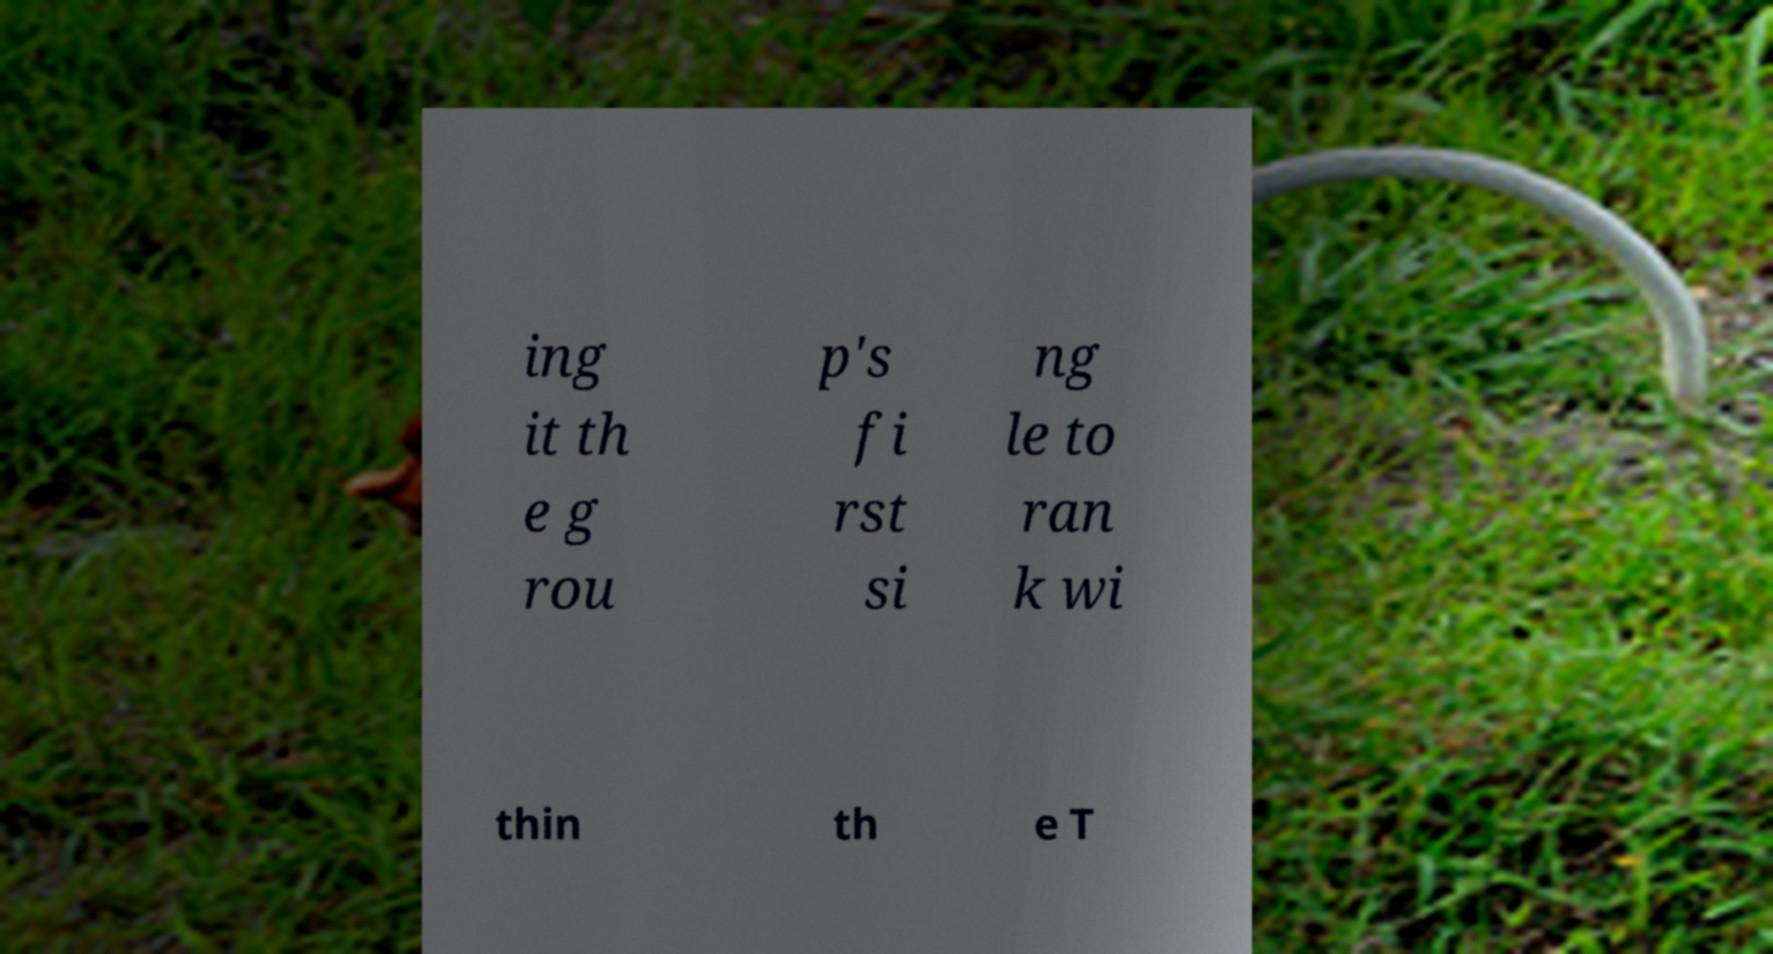Could you assist in decoding the text presented in this image and type it out clearly? ing it th e g rou p's fi rst si ng le to ran k wi thin th e T 